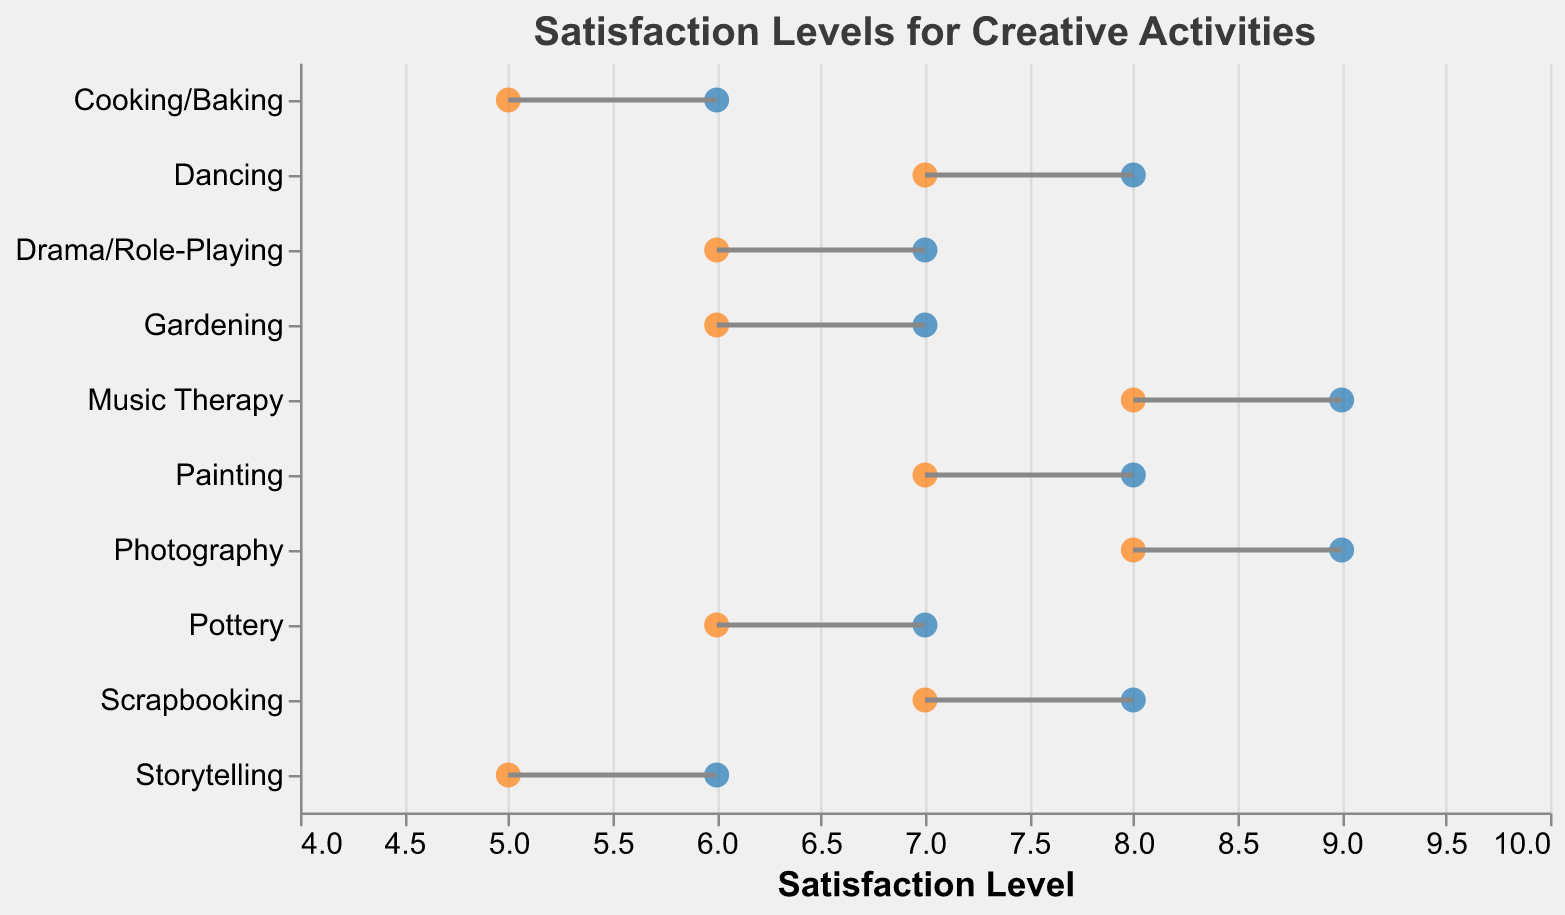What does the title of the figure indicate? The title of the figure is "Satisfaction Levels for Creative Activities," which indicates that the plot shows the satisfaction levels of family members and caregivers for different creative activities.
Answer: Satisfaction Levels for Creative Activities How are family members' and caregivers' satisfaction levels visually distinguished in the plot? Family members' satisfaction levels are shown using blue-colored dots, while caregivers' satisfaction levels are represented with orange-colored dots. The lines connecting these dots help indicate the relationship between the two satisfaction levels for each activity.
Answer: Blue for family members, orange for caregivers Which activity has the highest satisfaction level for both family members and caregivers? Music Therapy and Photography have the highest satisfaction levels, with family members rating them as 9 and caregivers as 8.
Answer: Music Therapy and Photography What is the range of satisfaction levels for Cooking/Baking? For Cooking/Baking, the satisfaction level for family members is 6 and for caregivers is 5, so the range is from 5 to 6.
Answer: 5 to 6 Which activity has the largest discrepancy in satisfaction levels between family members and caregivers? Storytelling and Cooking/Baking both have a discrepancy of 1 point, where family members rate the satisfaction as 6 and caregivers rate it as 5.
Answer: Storytelling and Cooking/Baking Is there any activity where family members' and caregivers' satisfaction levels are equal? No, there are no activities where family members' and caregivers' satisfaction levels are equal; there is always a difference of at least 1 point.
Answer: No What is the average satisfaction level for family members across all activities? The sum of family members' satisfaction levels is 75 (8+9+7+8+6+8+7+6+7+9), and there are 10 activities. The average satisfaction level is 75/10 = 7.5.
Answer: 7.5 What activity has the lowest satisfaction level for both family members and caregivers? Storytelling and Cooking/Baking have the lowest satisfaction levels, with family members rating them as 6 and caregivers rating them as 5.
Answer: Storytelling and Cooking/Baking 